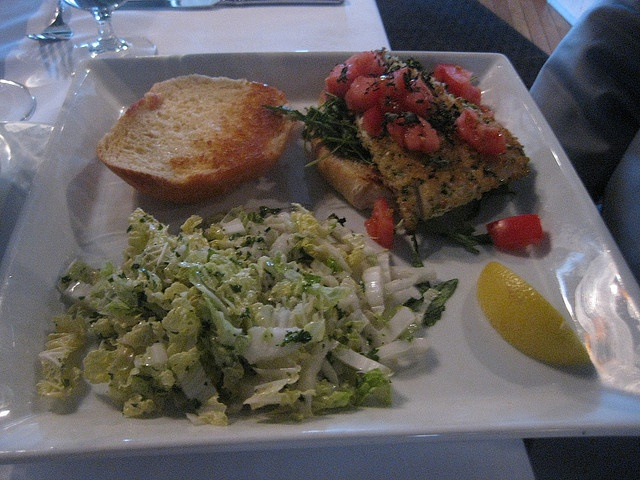Describe the objects in this image and their specific colors. I can see dining table in gray, black, and olive tones, sandwich in gray, black, and maroon tones, sandwich in gray, maroon, and brown tones, people in gray, black, and darkblue tones, and wine glass in gray and darkgray tones in this image. 